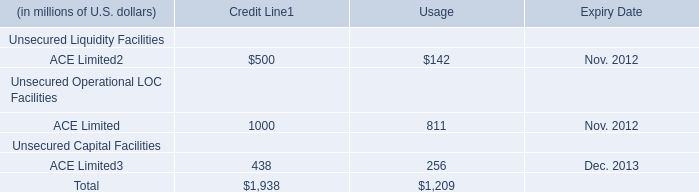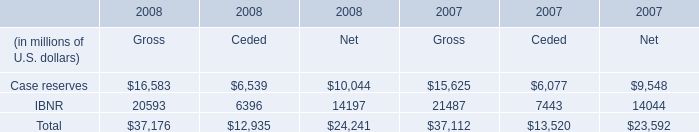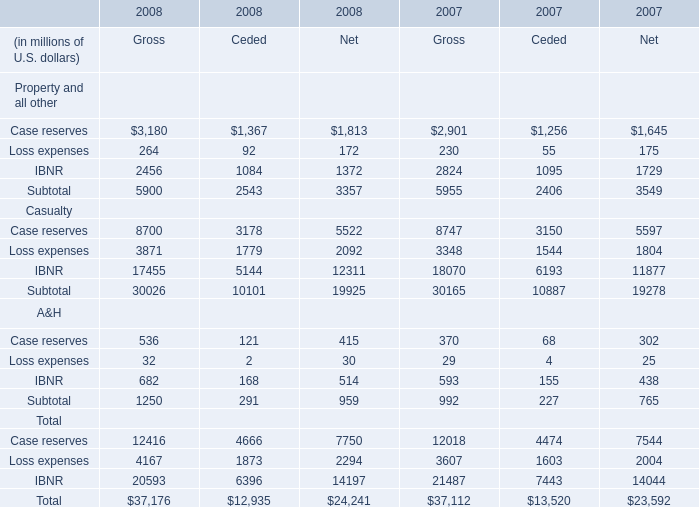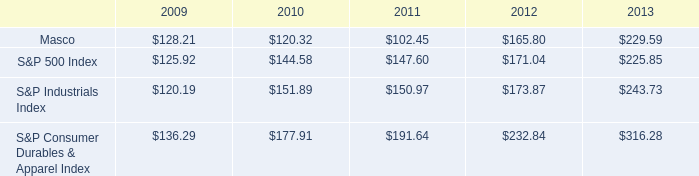What was the total amount of the Case reserves for Net in the year where Case reserves for Ceded is greater than 6500? (in millions of U.S. dollars) 
Answer: 10044. 